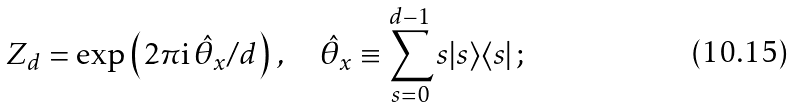Convert formula to latex. <formula><loc_0><loc_0><loc_500><loc_500>Z _ { d } = \exp \left ( 2 \pi \text {i} \, \hat { \theta } _ { x } / d \right ) \, , \quad \hat { \theta } _ { x } \equiv \sum _ { s = 0 } ^ { d - 1 } s | s \rangle \langle s | \, ;</formula> 